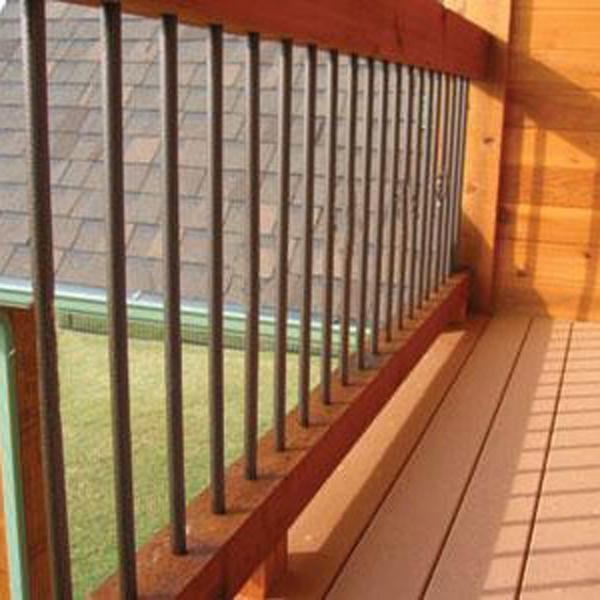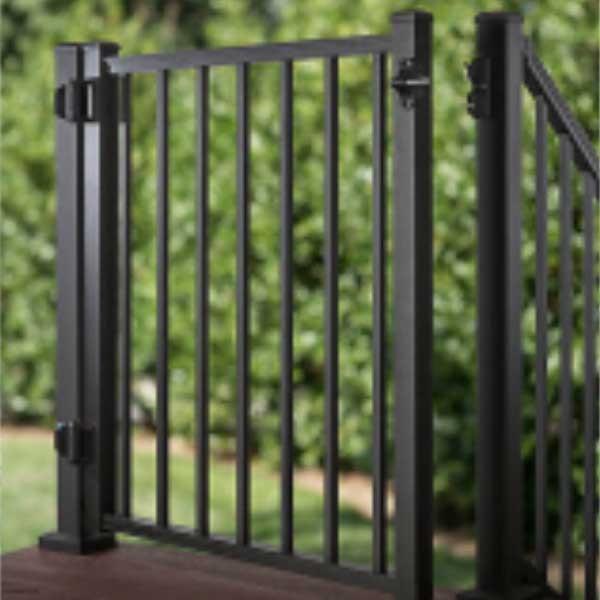The first image is the image on the left, the second image is the image on the right. For the images displayed, is the sentence "One image shows an all-black metal gate with hinges on the left and the latch on the right." factually correct? Answer yes or no. Yes. The first image is the image on the left, the second image is the image on the right. Given the left and right images, does the statement "There are railings made of wood in each image" hold true? Answer yes or no. No. 